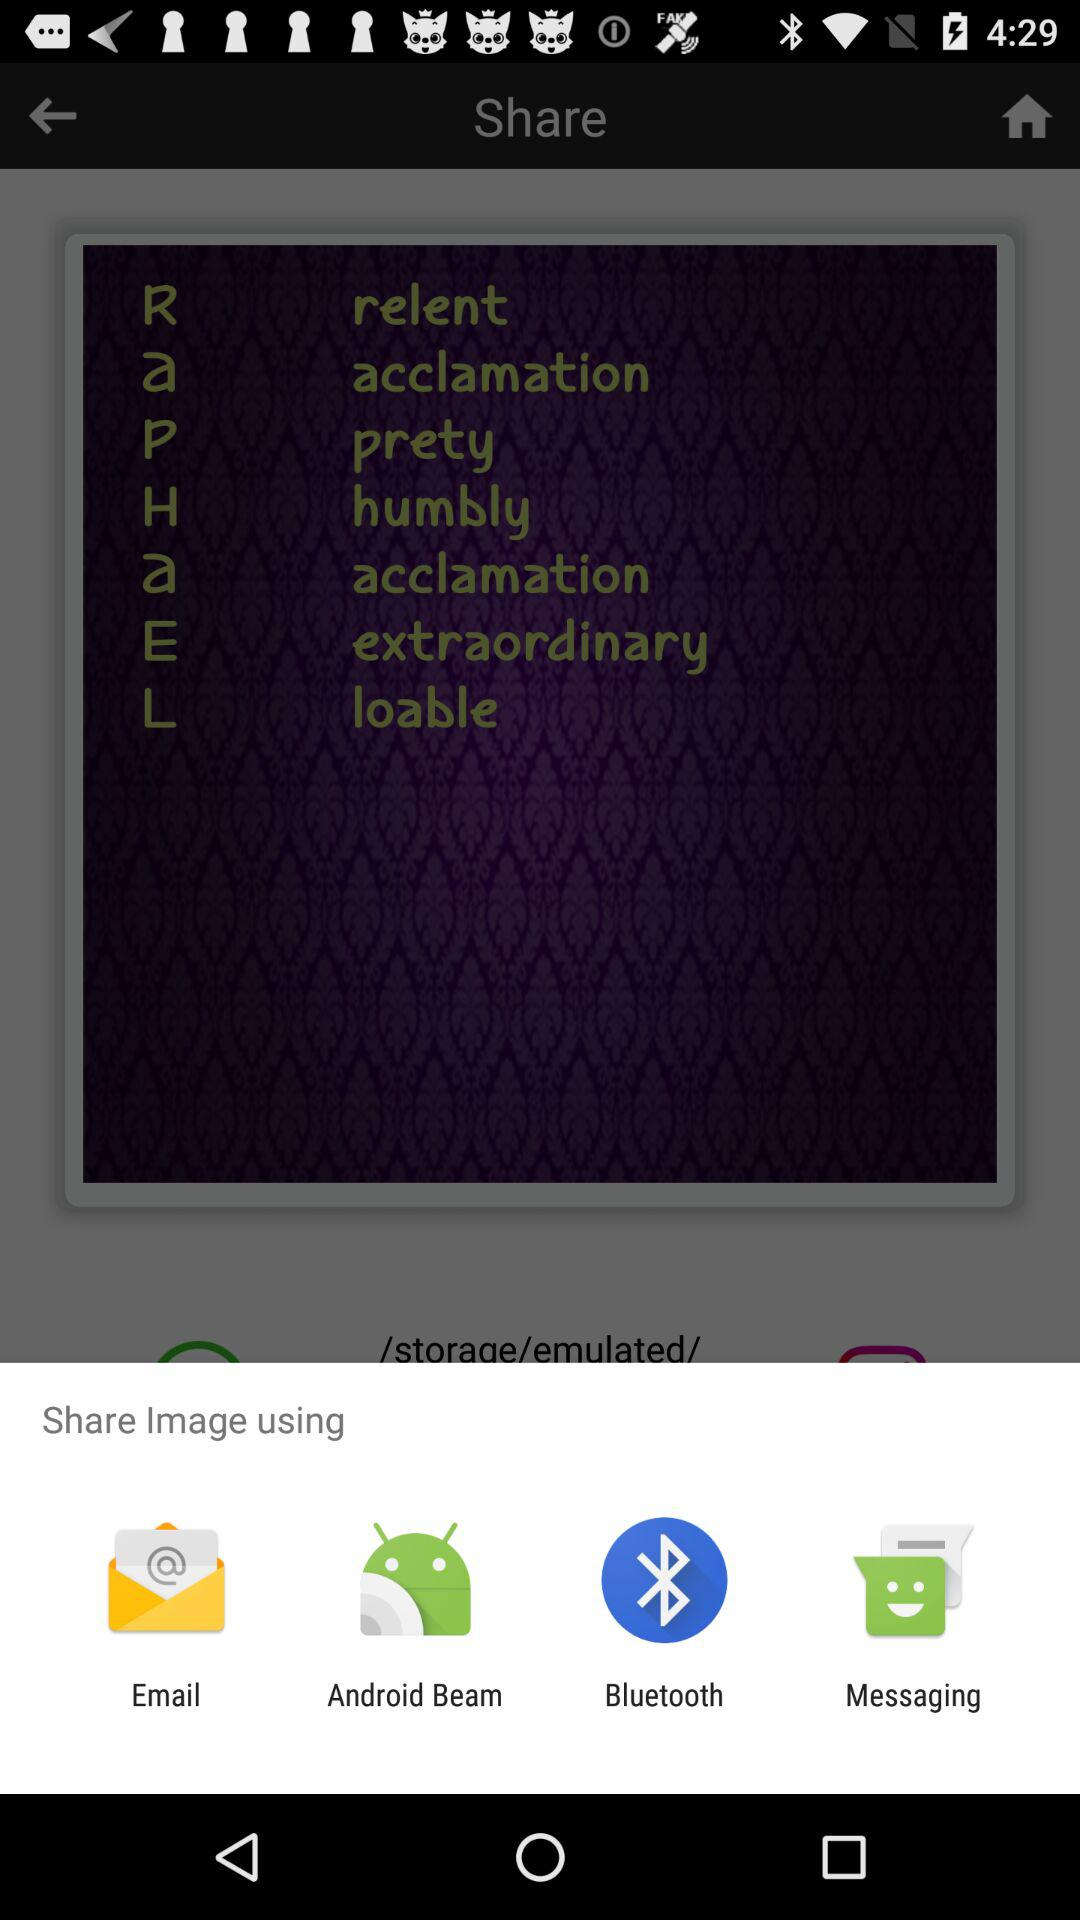What applications can be used to share? The applications that can be used to share are "Email", "Android Beam", "Bluetooth" and "Messaging". 